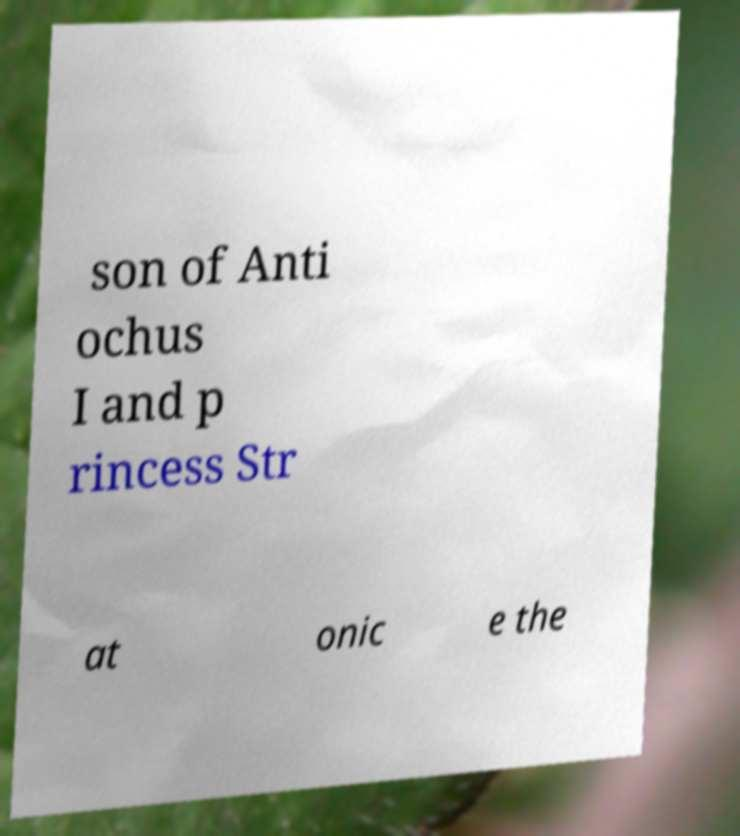For documentation purposes, I need the text within this image transcribed. Could you provide that? son of Anti ochus I and p rincess Str at onic e the 